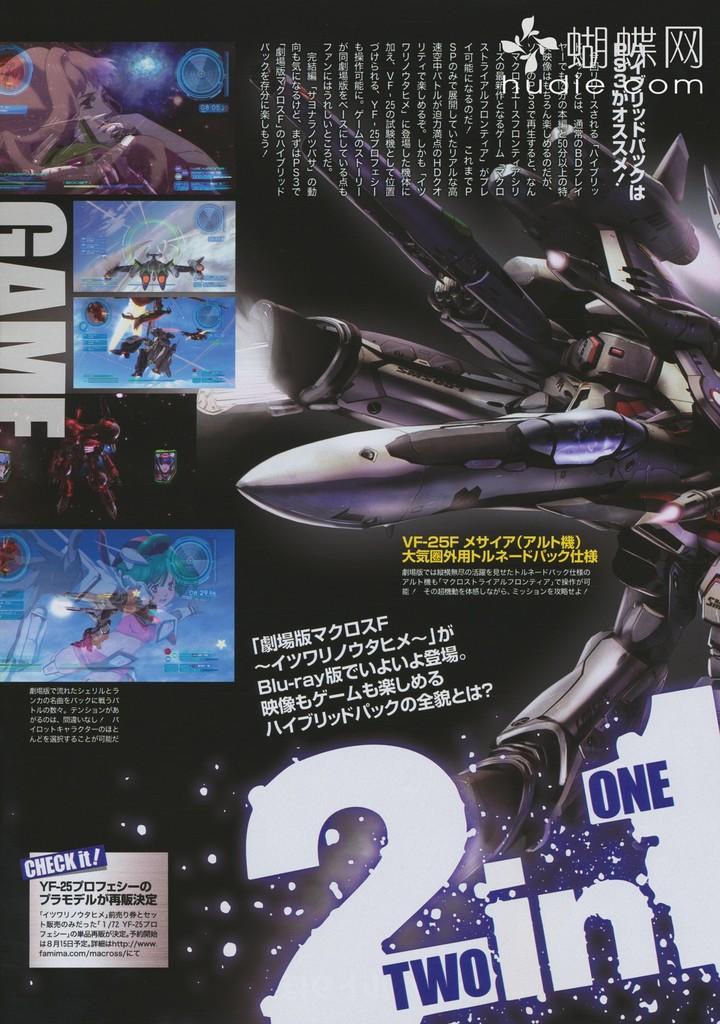What type of game is this?
Offer a terse response. 2 in 1. 